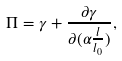<formula> <loc_0><loc_0><loc_500><loc_500>\Pi = \gamma + \frac { \partial \gamma } { \partial ( \alpha \frac { l } { l _ { 0 } } ) } ,</formula> 